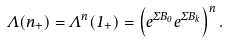<formula> <loc_0><loc_0><loc_500><loc_500>\Lambda ( n _ { + } ) = \Lambda ^ { n } ( 1 _ { + } ) = \left ( e ^ { \Sigma B _ { 0 } } e ^ { \Sigma B _ { k } } \right ) ^ { n } .</formula> 